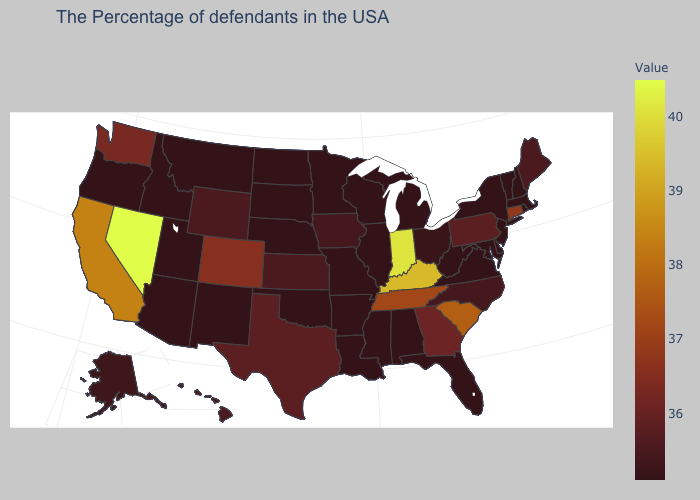Does Kansas have the lowest value in the MidWest?
Quick response, please. No. Is the legend a continuous bar?
Concise answer only. Yes. Does the map have missing data?
Quick response, please. No. Does Indiana have the highest value in the USA?
Quick response, please. No. Among the states that border Arizona , which have the lowest value?
Give a very brief answer. New Mexico, Utah. 